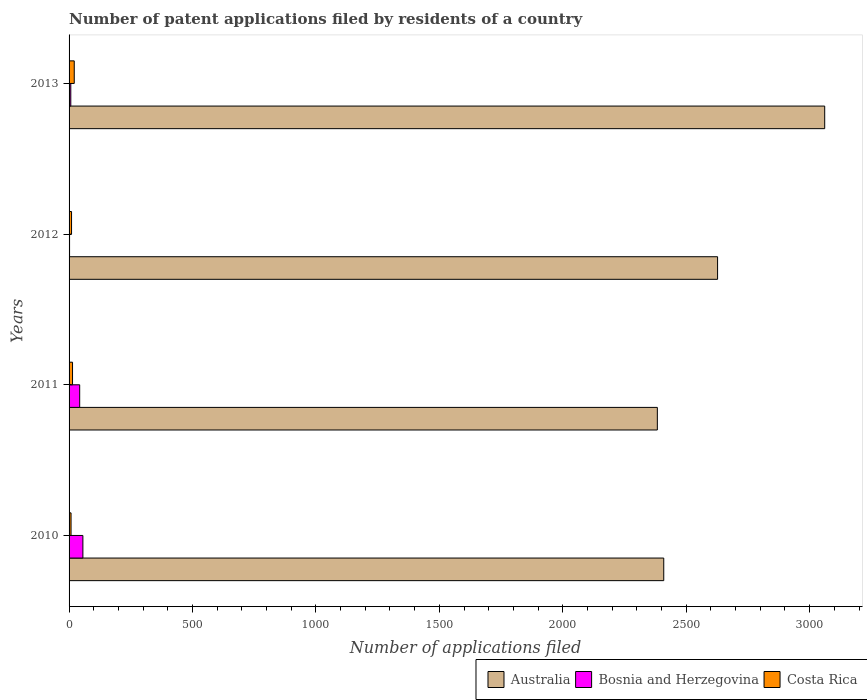How many different coloured bars are there?
Your answer should be very brief. 3. Are the number of bars per tick equal to the number of legend labels?
Your answer should be very brief. Yes. How many bars are there on the 1st tick from the top?
Your response must be concise. 3. In how many cases, is the number of bars for a given year not equal to the number of legend labels?
Give a very brief answer. 0. What is the number of applications filed in Costa Rica in 2013?
Your response must be concise. 21. Across all years, what is the maximum number of applications filed in Costa Rica?
Your answer should be compact. 21. Across all years, what is the minimum number of applications filed in Australia?
Your answer should be very brief. 2383. What is the total number of applications filed in Australia in the graph?
Offer a terse response. 1.05e+04. What is the difference between the number of applications filed in Australia in 2011 and that in 2012?
Ensure brevity in your answer.  -244. What is the difference between the number of applications filed in Australia in 2011 and the number of applications filed in Costa Rica in 2012?
Your answer should be very brief. 2373. What is the average number of applications filed in Costa Rica per year?
Offer a very short reply. 13.25. In the year 2013, what is the difference between the number of applications filed in Bosnia and Herzegovina and number of applications filed in Australia?
Your answer should be very brief. -3054. What is the ratio of the number of applications filed in Australia in 2010 to that in 2012?
Your answer should be very brief. 0.92. What is the difference between the highest and the lowest number of applications filed in Australia?
Provide a short and direct response. 678. In how many years, is the number of applications filed in Costa Rica greater than the average number of applications filed in Costa Rica taken over all years?
Keep it short and to the point. 2. Is the sum of the number of applications filed in Costa Rica in 2012 and 2013 greater than the maximum number of applications filed in Bosnia and Herzegovina across all years?
Ensure brevity in your answer.  No. What does the 2nd bar from the top in 2012 represents?
Your response must be concise. Bosnia and Herzegovina. Is it the case that in every year, the sum of the number of applications filed in Bosnia and Herzegovina and number of applications filed in Costa Rica is greater than the number of applications filed in Australia?
Your answer should be very brief. No. How many bars are there?
Offer a terse response. 12. How many years are there in the graph?
Your answer should be very brief. 4. What is the difference between two consecutive major ticks on the X-axis?
Provide a succinct answer. 500. Are the values on the major ticks of X-axis written in scientific E-notation?
Make the answer very short. No. Does the graph contain grids?
Your answer should be very brief. No. Where does the legend appear in the graph?
Give a very brief answer. Bottom right. How many legend labels are there?
Keep it short and to the point. 3. What is the title of the graph?
Give a very brief answer. Number of patent applications filed by residents of a country. Does "Guam" appear as one of the legend labels in the graph?
Keep it short and to the point. No. What is the label or title of the X-axis?
Keep it short and to the point. Number of applications filed. What is the label or title of the Y-axis?
Keep it short and to the point. Years. What is the Number of applications filed in Australia in 2010?
Make the answer very short. 2409. What is the Number of applications filed of Bosnia and Herzegovina in 2010?
Offer a terse response. 56. What is the Number of applications filed of Australia in 2011?
Keep it short and to the point. 2383. What is the Number of applications filed in Costa Rica in 2011?
Provide a succinct answer. 14. What is the Number of applications filed of Australia in 2012?
Ensure brevity in your answer.  2627. What is the Number of applications filed of Australia in 2013?
Make the answer very short. 3061. What is the Number of applications filed of Bosnia and Herzegovina in 2013?
Provide a short and direct response. 7. Across all years, what is the maximum Number of applications filed in Australia?
Provide a short and direct response. 3061. Across all years, what is the minimum Number of applications filed of Australia?
Your answer should be very brief. 2383. Across all years, what is the minimum Number of applications filed in Bosnia and Herzegovina?
Offer a terse response. 2. Across all years, what is the minimum Number of applications filed in Costa Rica?
Your response must be concise. 8. What is the total Number of applications filed in Australia in the graph?
Keep it short and to the point. 1.05e+04. What is the total Number of applications filed of Bosnia and Herzegovina in the graph?
Keep it short and to the point. 108. What is the difference between the Number of applications filed in Bosnia and Herzegovina in 2010 and that in 2011?
Make the answer very short. 13. What is the difference between the Number of applications filed of Costa Rica in 2010 and that in 2011?
Your response must be concise. -6. What is the difference between the Number of applications filed of Australia in 2010 and that in 2012?
Provide a succinct answer. -218. What is the difference between the Number of applications filed of Bosnia and Herzegovina in 2010 and that in 2012?
Your answer should be compact. 54. What is the difference between the Number of applications filed of Australia in 2010 and that in 2013?
Provide a short and direct response. -652. What is the difference between the Number of applications filed in Australia in 2011 and that in 2012?
Offer a very short reply. -244. What is the difference between the Number of applications filed in Costa Rica in 2011 and that in 2012?
Give a very brief answer. 4. What is the difference between the Number of applications filed in Australia in 2011 and that in 2013?
Keep it short and to the point. -678. What is the difference between the Number of applications filed of Costa Rica in 2011 and that in 2013?
Your answer should be compact. -7. What is the difference between the Number of applications filed of Australia in 2012 and that in 2013?
Make the answer very short. -434. What is the difference between the Number of applications filed of Costa Rica in 2012 and that in 2013?
Offer a terse response. -11. What is the difference between the Number of applications filed of Australia in 2010 and the Number of applications filed of Bosnia and Herzegovina in 2011?
Your response must be concise. 2366. What is the difference between the Number of applications filed of Australia in 2010 and the Number of applications filed of Costa Rica in 2011?
Make the answer very short. 2395. What is the difference between the Number of applications filed of Bosnia and Herzegovina in 2010 and the Number of applications filed of Costa Rica in 2011?
Ensure brevity in your answer.  42. What is the difference between the Number of applications filed of Australia in 2010 and the Number of applications filed of Bosnia and Herzegovina in 2012?
Provide a succinct answer. 2407. What is the difference between the Number of applications filed of Australia in 2010 and the Number of applications filed of Costa Rica in 2012?
Give a very brief answer. 2399. What is the difference between the Number of applications filed of Bosnia and Herzegovina in 2010 and the Number of applications filed of Costa Rica in 2012?
Your answer should be very brief. 46. What is the difference between the Number of applications filed in Australia in 2010 and the Number of applications filed in Bosnia and Herzegovina in 2013?
Offer a very short reply. 2402. What is the difference between the Number of applications filed of Australia in 2010 and the Number of applications filed of Costa Rica in 2013?
Offer a very short reply. 2388. What is the difference between the Number of applications filed in Bosnia and Herzegovina in 2010 and the Number of applications filed in Costa Rica in 2013?
Give a very brief answer. 35. What is the difference between the Number of applications filed of Australia in 2011 and the Number of applications filed of Bosnia and Herzegovina in 2012?
Make the answer very short. 2381. What is the difference between the Number of applications filed of Australia in 2011 and the Number of applications filed of Costa Rica in 2012?
Offer a very short reply. 2373. What is the difference between the Number of applications filed in Australia in 2011 and the Number of applications filed in Bosnia and Herzegovina in 2013?
Make the answer very short. 2376. What is the difference between the Number of applications filed of Australia in 2011 and the Number of applications filed of Costa Rica in 2013?
Offer a very short reply. 2362. What is the difference between the Number of applications filed in Australia in 2012 and the Number of applications filed in Bosnia and Herzegovina in 2013?
Provide a short and direct response. 2620. What is the difference between the Number of applications filed of Australia in 2012 and the Number of applications filed of Costa Rica in 2013?
Give a very brief answer. 2606. What is the average Number of applications filed in Australia per year?
Your answer should be very brief. 2620. What is the average Number of applications filed of Costa Rica per year?
Make the answer very short. 13.25. In the year 2010, what is the difference between the Number of applications filed in Australia and Number of applications filed in Bosnia and Herzegovina?
Ensure brevity in your answer.  2353. In the year 2010, what is the difference between the Number of applications filed in Australia and Number of applications filed in Costa Rica?
Your answer should be very brief. 2401. In the year 2011, what is the difference between the Number of applications filed of Australia and Number of applications filed of Bosnia and Herzegovina?
Make the answer very short. 2340. In the year 2011, what is the difference between the Number of applications filed in Australia and Number of applications filed in Costa Rica?
Ensure brevity in your answer.  2369. In the year 2012, what is the difference between the Number of applications filed of Australia and Number of applications filed of Bosnia and Herzegovina?
Offer a very short reply. 2625. In the year 2012, what is the difference between the Number of applications filed of Australia and Number of applications filed of Costa Rica?
Make the answer very short. 2617. In the year 2013, what is the difference between the Number of applications filed of Australia and Number of applications filed of Bosnia and Herzegovina?
Provide a succinct answer. 3054. In the year 2013, what is the difference between the Number of applications filed of Australia and Number of applications filed of Costa Rica?
Ensure brevity in your answer.  3040. In the year 2013, what is the difference between the Number of applications filed in Bosnia and Herzegovina and Number of applications filed in Costa Rica?
Your response must be concise. -14. What is the ratio of the Number of applications filed of Australia in 2010 to that in 2011?
Your answer should be very brief. 1.01. What is the ratio of the Number of applications filed in Bosnia and Herzegovina in 2010 to that in 2011?
Your response must be concise. 1.3. What is the ratio of the Number of applications filed of Australia in 2010 to that in 2012?
Keep it short and to the point. 0.92. What is the ratio of the Number of applications filed in Bosnia and Herzegovina in 2010 to that in 2012?
Offer a terse response. 28. What is the ratio of the Number of applications filed of Australia in 2010 to that in 2013?
Offer a terse response. 0.79. What is the ratio of the Number of applications filed of Bosnia and Herzegovina in 2010 to that in 2013?
Offer a terse response. 8. What is the ratio of the Number of applications filed in Costa Rica in 2010 to that in 2013?
Your answer should be very brief. 0.38. What is the ratio of the Number of applications filed of Australia in 2011 to that in 2012?
Give a very brief answer. 0.91. What is the ratio of the Number of applications filed in Costa Rica in 2011 to that in 2012?
Ensure brevity in your answer.  1.4. What is the ratio of the Number of applications filed of Australia in 2011 to that in 2013?
Provide a short and direct response. 0.78. What is the ratio of the Number of applications filed of Bosnia and Herzegovina in 2011 to that in 2013?
Your answer should be very brief. 6.14. What is the ratio of the Number of applications filed in Costa Rica in 2011 to that in 2013?
Provide a succinct answer. 0.67. What is the ratio of the Number of applications filed in Australia in 2012 to that in 2013?
Offer a very short reply. 0.86. What is the ratio of the Number of applications filed of Bosnia and Herzegovina in 2012 to that in 2013?
Make the answer very short. 0.29. What is the ratio of the Number of applications filed in Costa Rica in 2012 to that in 2013?
Give a very brief answer. 0.48. What is the difference between the highest and the second highest Number of applications filed in Australia?
Make the answer very short. 434. What is the difference between the highest and the second highest Number of applications filed of Bosnia and Herzegovina?
Your response must be concise. 13. What is the difference between the highest and the lowest Number of applications filed of Australia?
Your answer should be very brief. 678. What is the difference between the highest and the lowest Number of applications filed in Bosnia and Herzegovina?
Your response must be concise. 54. What is the difference between the highest and the lowest Number of applications filed in Costa Rica?
Provide a succinct answer. 13. 